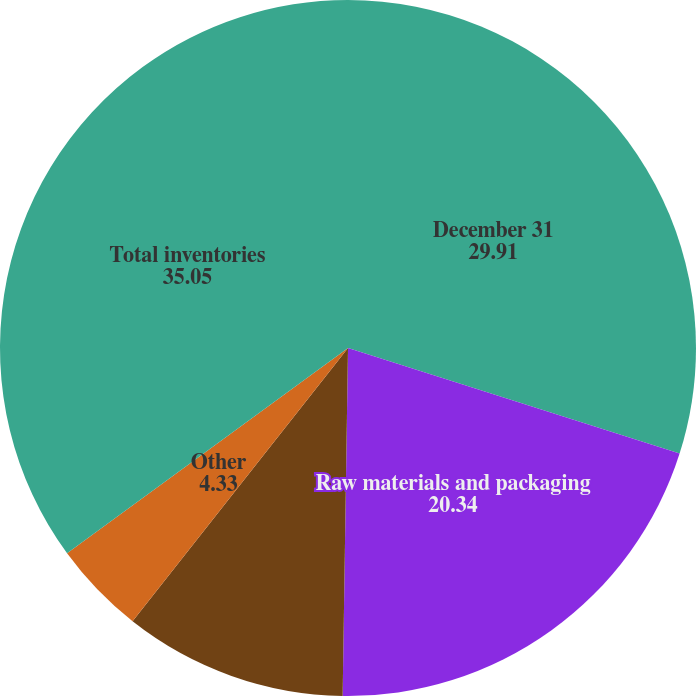<chart> <loc_0><loc_0><loc_500><loc_500><pie_chart><fcel>December 31<fcel>Raw materials and packaging<fcel>Finished goods<fcel>Other<fcel>Total inventories<nl><fcel>29.91%<fcel>20.34%<fcel>10.38%<fcel>4.33%<fcel>35.05%<nl></chart> 